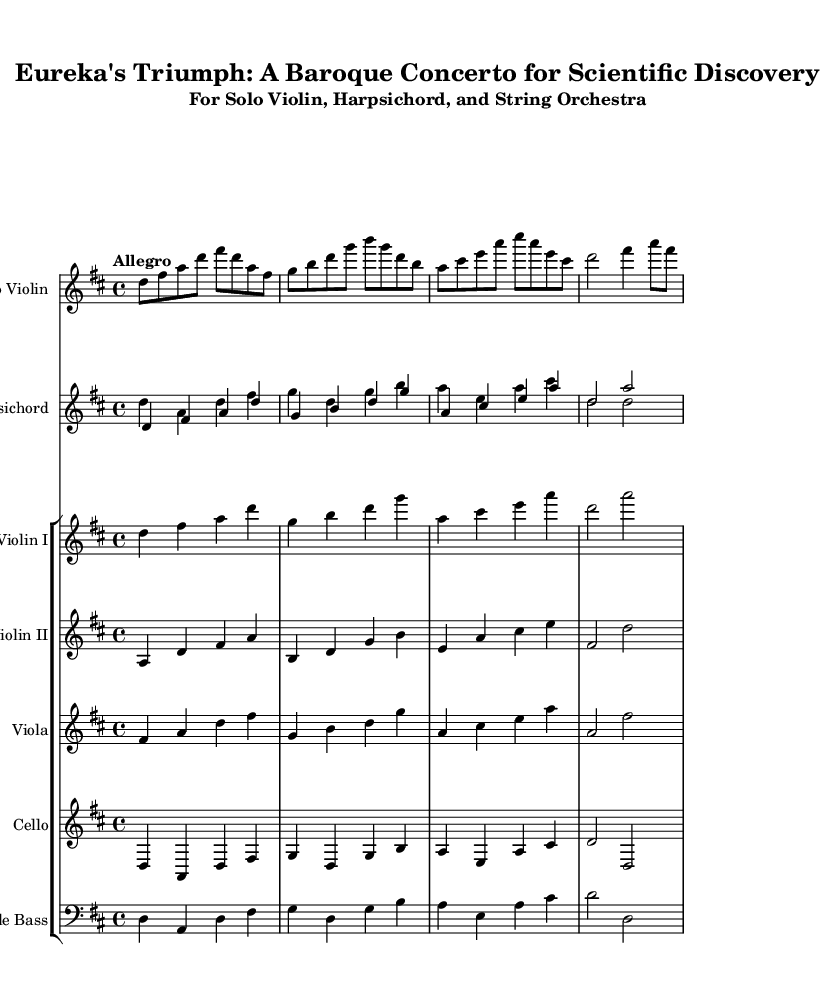What is the key signature of this music? The key signature is D major, which features two sharps: F# and C#.
Answer: D major What is the time signature of this music? The time signature, indicated at the beginning of the piece, is 4/4, which means there are four beats in a measure.
Answer: 4/4 What is the tempo marking given for this piece? The tempo marking at the beginning states "Allegro," which indicates a fast and lively pace.
Answer: Allegro How many instruments are in the ensemble? The score includes a solo violin, harpsichord, and a string orchestra consisting of two violins, a viola, cello, and double bass, totaling seven instruments.
Answer: Seven instruments What is the role of the harpsichord in this concerto? The harpsichord is primarily supporting harmonies and providing a continuo part while also having melodic lines in conjunction with the strings.
Answer: Accompaniment and continuo Which instrument has the solo part? The solo part is designated for the violin, which plays distinct and expressive melodies throughout the piece.
Answer: Violin Name a characteristic feature of Baroque concertos evident in this piece. The piece displays a typical feature of the Baroque concerto through the alternation between solo and ensemble sections, showcasing the soloist's virtuosity contrasted with a full orchestral backdrop.
Answer: Solo and ensemble alternation 